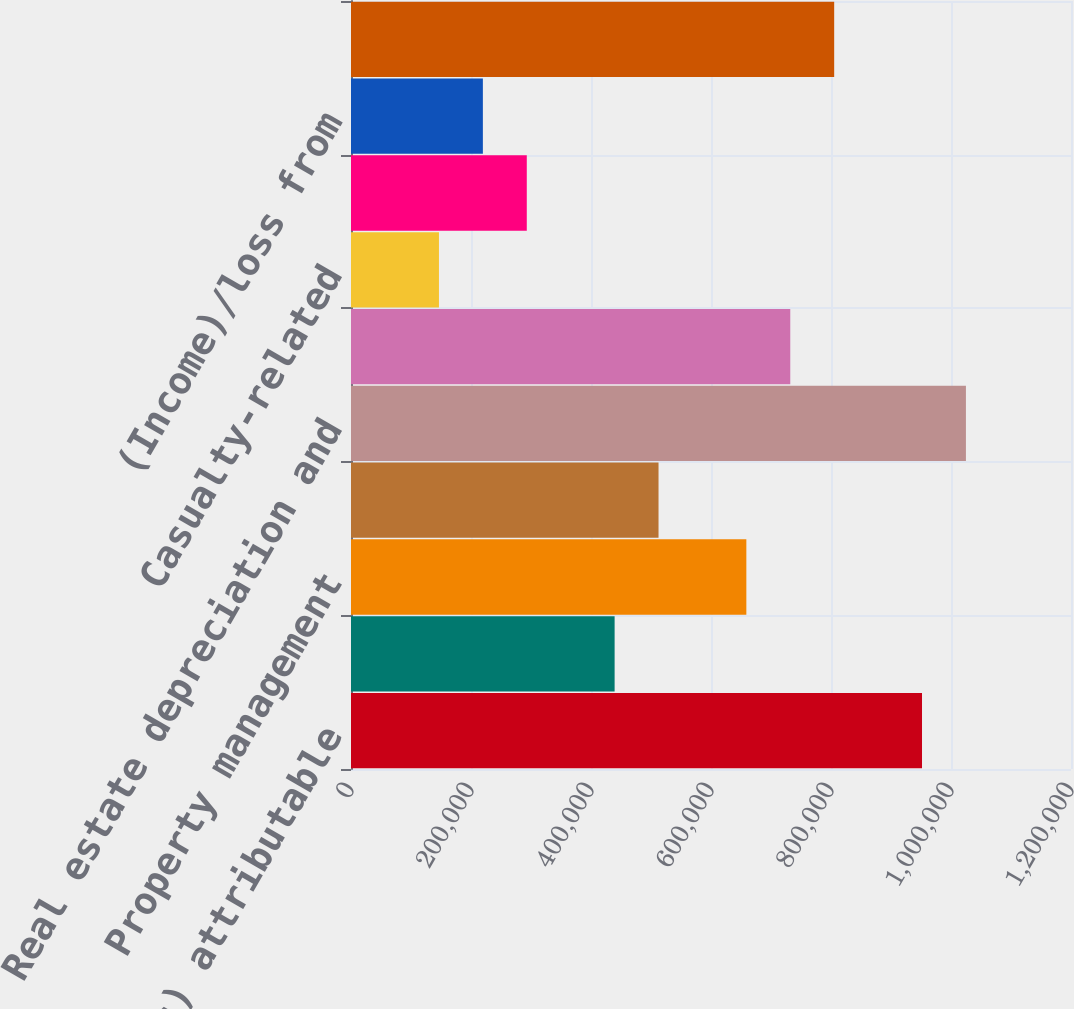Convert chart to OTSL. <chart><loc_0><loc_0><loc_500><loc_500><bar_chart><fcel>Net income/(loss) attributable<fcel>Joint venture management and<fcel>Property management<fcel>Other operating expenses<fcel>Real estate depreciation and<fcel>General and administrative<fcel>Casualty-related<fcel>Other depreciation and<fcel>(Income)/loss from<fcel>Interest expense<nl><fcel>951683<fcel>439357<fcel>658926<fcel>512547<fcel>1.02487e+06<fcel>732115<fcel>146600<fcel>292979<fcel>219789<fcel>805304<nl></chart> 